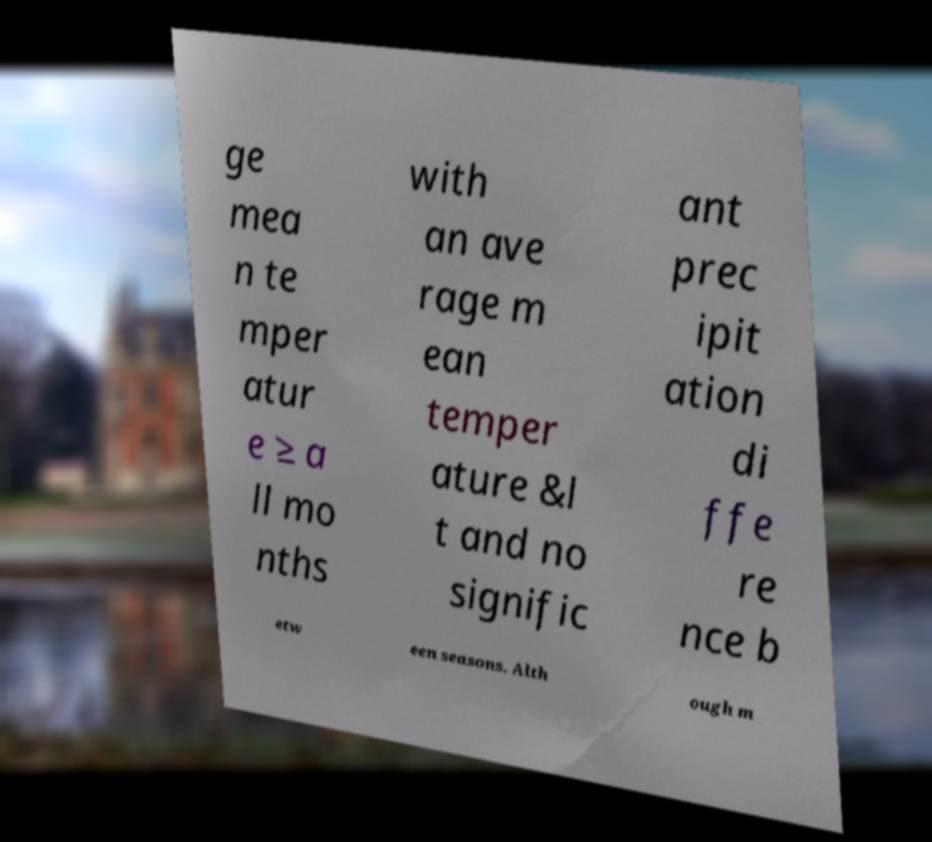For documentation purposes, I need the text within this image transcribed. Could you provide that? ge mea n te mper atur e ≥ a ll mo nths with an ave rage m ean temper ature &l t and no signific ant prec ipit ation di ffe re nce b etw een seasons. Alth ough m 